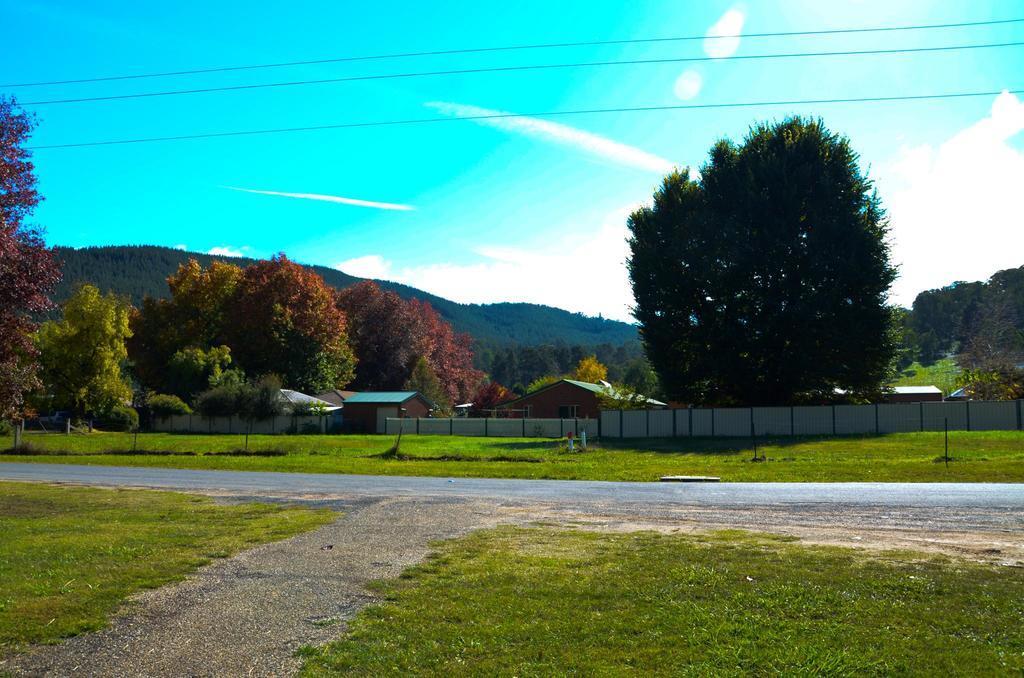Please provide a concise description of this image. In this image there is grass on the ground. Beside it there is a road. On the other side of the road there is grass. In the background there are trees and houses. Around the houses there is a fence. Behind the trees there are mountains. At the top there is the sky. 